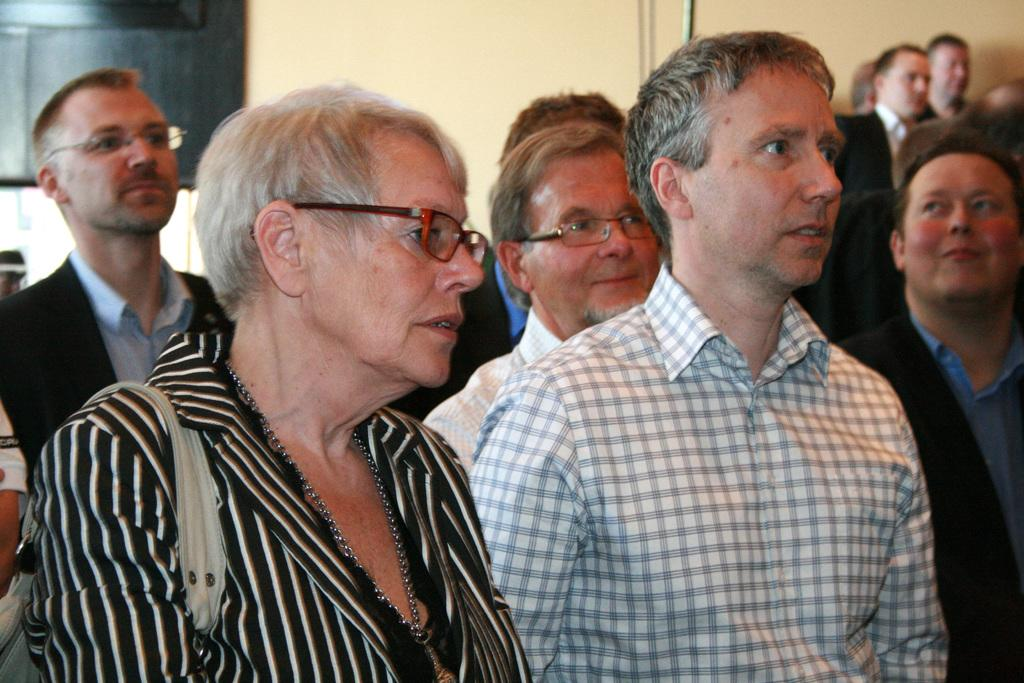How many people are in the image? There is a group of persons in the image. What are the persons doing in the image? The persons are standing on the floor. What can be seen in the background of the image? There is a wall in the background of the image. What type of soap is being used by the persons in the image? There is no soap present in the image; the persons are simply standing on the floor. How many times do the persons fall in the image? The persons are not falling in the image; they are standing on the floor. 